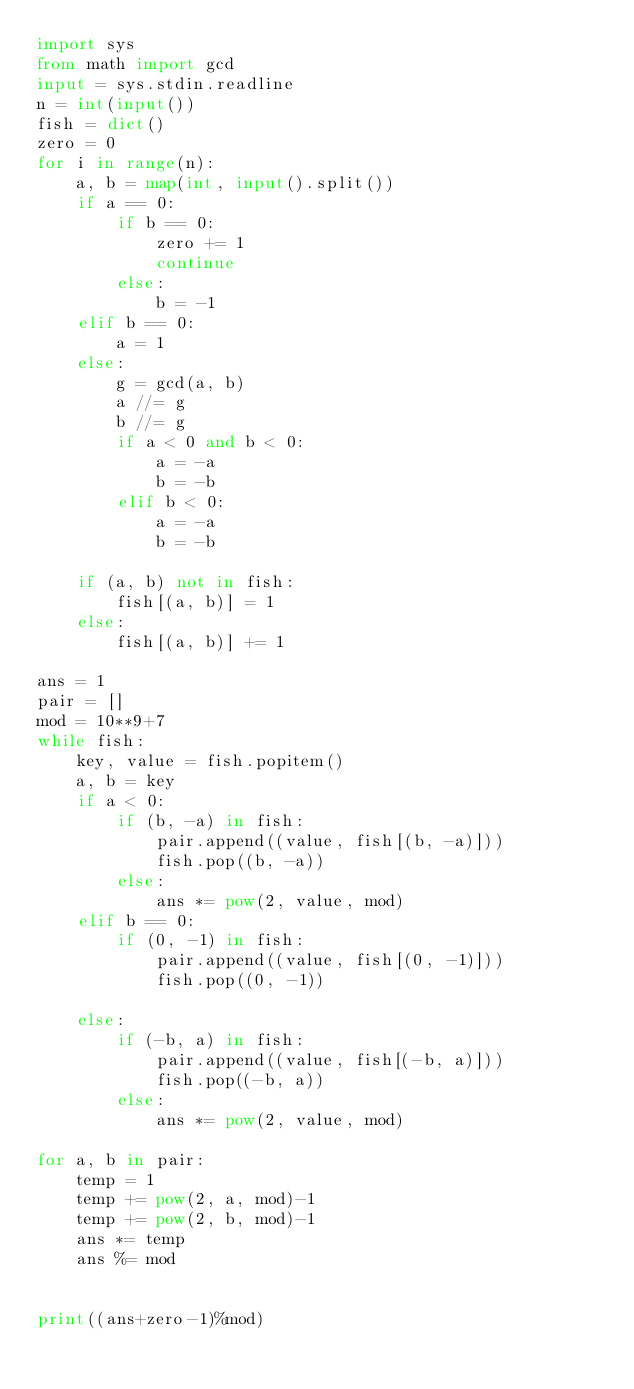<code> <loc_0><loc_0><loc_500><loc_500><_Python_>import sys
from math import gcd
input = sys.stdin.readline
n = int(input())
fish = dict()
zero = 0
for i in range(n):
    a, b = map(int, input().split())
    if a == 0:
        if b == 0:
            zero += 1
            continue
        else:
            b = -1
    elif b == 0:
        a = 1
    else:
        g = gcd(a, b)
        a //= g
        b //= g
        if a < 0 and b < 0:
            a = -a
            b = -b
        elif b < 0:
            a = -a
            b = -b

    if (a, b) not in fish:
        fish[(a, b)] = 1
    else:
        fish[(a, b)] += 1

ans = 1
pair = []
mod = 10**9+7
while fish:
    key, value = fish.popitem()
    a, b = key
    if a < 0:
        if (b, -a) in fish:
            pair.append((value, fish[(b, -a)]))
            fish.pop((b, -a))
        else:
            ans *= pow(2, value, mod)
    elif b == 0:
        if (0, -1) in fish:
            pair.append((value, fish[(0, -1)]))
            fish.pop((0, -1))

    else:
        if (-b, a) in fish:
            pair.append((value, fish[(-b, a)]))
            fish.pop((-b, a))
        else:
            ans *= pow(2, value, mod)

for a, b in pair:
    temp = 1
    temp += pow(2, a, mod)-1
    temp += pow(2, b, mod)-1
    ans *= temp
    ans %= mod


print((ans+zero-1)%mod)
</code> 